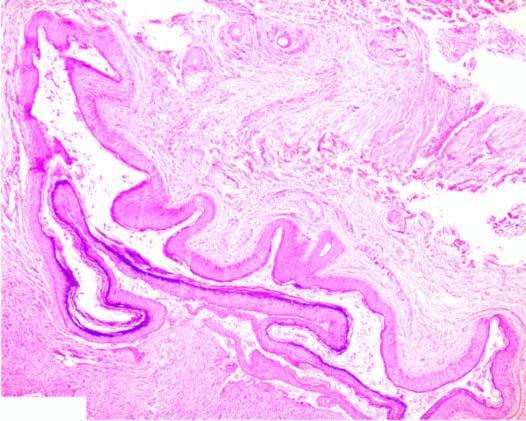does taghorn renal stone with chronic pyelonephritisthe kidney have adnexal structures in the cyst wall ie in addition to features of epidermal cyst?
Answer the question using a single word or phrase. No 